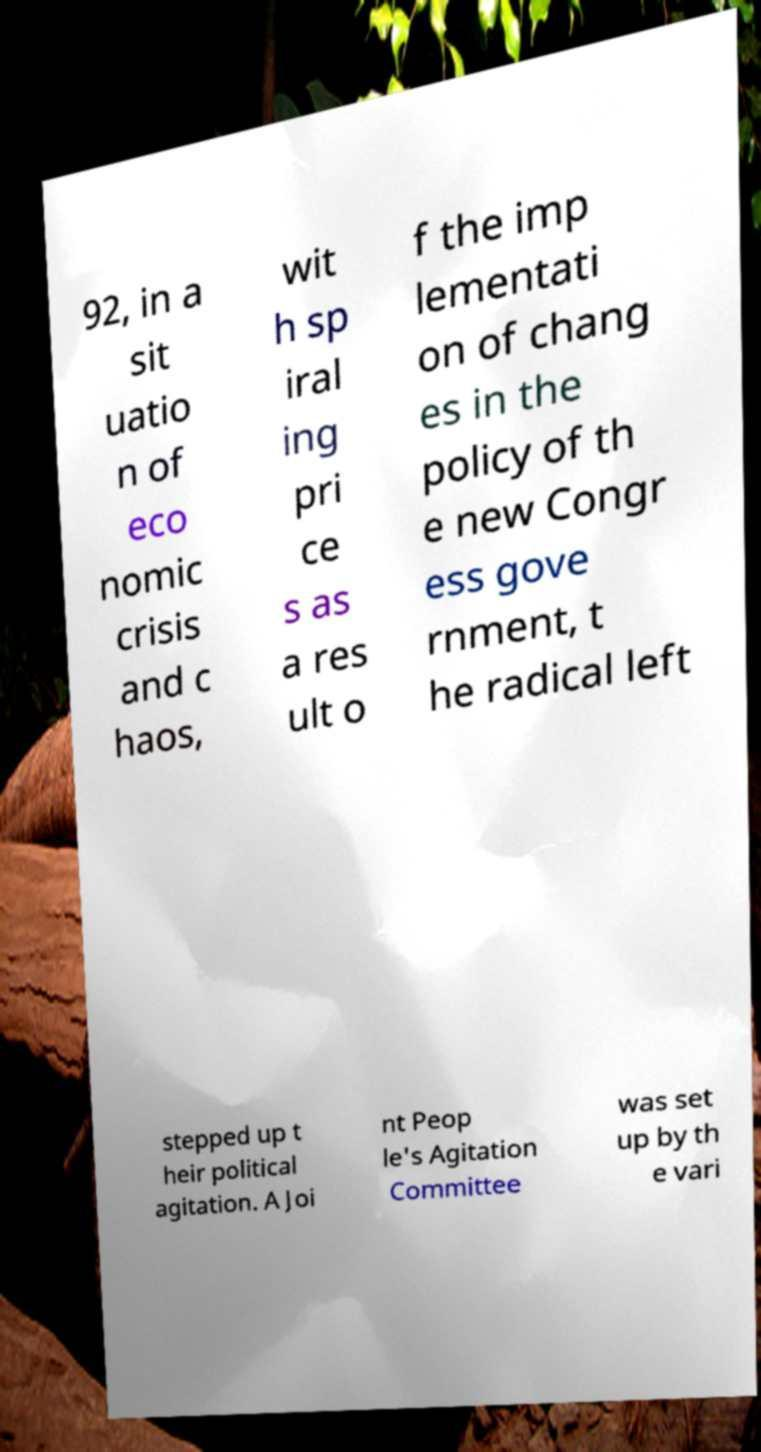Can you read and provide the text displayed in the image?This photo seems to have some interesting text. Can you extract and type it out for me? 92, in a sit uatio n of eco nomic crisis and c haos, wit h sp iral ing pri ce s as a res ult o f the imp lementati on of chang es in the policy of th e new Congr ess gove rnment, t he radical left stepped up t heir political agitation. A Joi nt Peop le's Agitation Committee was set up by th e vari 